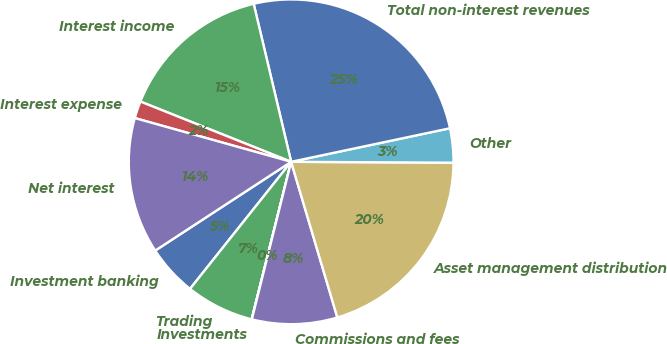<chart> <loc_0><loc_0><loc_500><loc_500><pie_chart><fcel>Investment banking<fcel>Trading<fcel>Investments<fcel>Commissions and fees<fcel>Asset management distribution<fcel>Other<fcel>Total non-interest revenues<fcel>Interest income<fcel>Interest expense<fcel>Net interest<nl><fcel>5.09%<fcel>6.79%<fcel>0.02%<fcel>8.48%<fcel>20.32%<fcel>3.4%<fcel>25.39%<fcel>15.24%<fcel>1.71%<fcel>13.55%<nl></chart> 